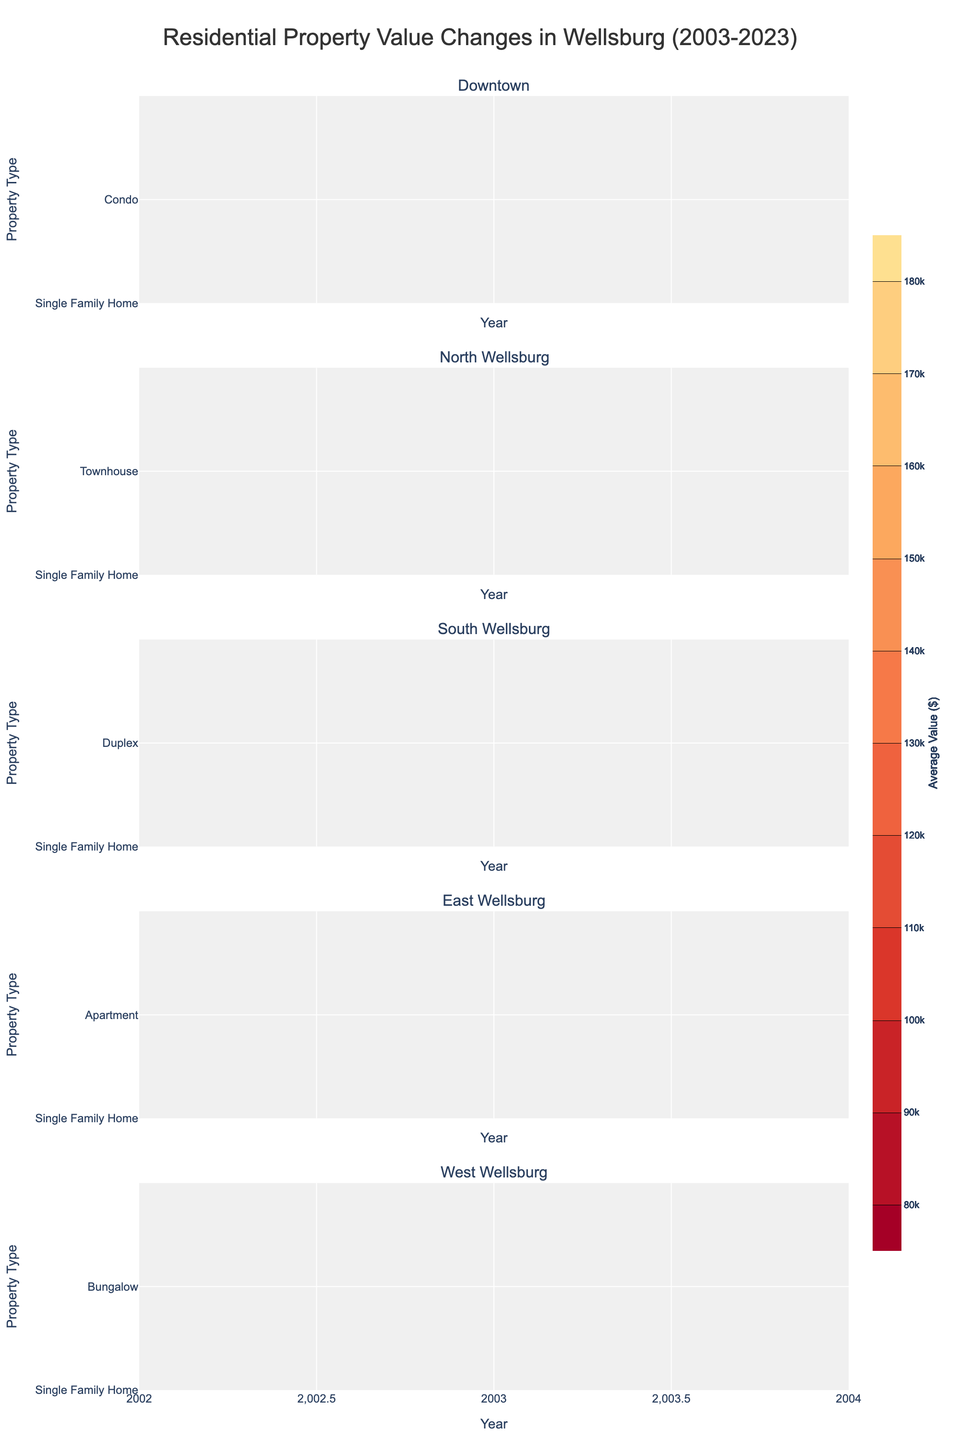What is the title of the figure? The title of the figure is displayed at the top of the plot. It provides an overview of what the entire figure represents.
Answer: Residential Property Value Changes in Wellsburg (2003-2023) Which neighborhood shows the highest increase in property value for Single Family Homes from 2003 to 2023? To find this, compare the contour lines for Single Family Homes across all neighborhoods from 2003 to 2023. Look for the largest increase in average value.
Answer: Downtown What is the average value of a Condo in Downtown Wellsburg in 2023? Look at the contour for Downtown and locate the values for Condos in 2023. The average value here can be read directly.
Answer: $150,000 How does the property value of Townhouses in North Wellsburg compare to Bungalows in West Wellsburg in 2023? Examine the contour lines for both property types in their respective neighborhoods for the year 2023. Compare the values directly.
Answer: Townhouses: $140,000, Bungalows: $130,000 Which neighborhood had the highest average property value for any property type in 2003? Check the contour plots for each neighborhood for the year 2003. Identify which property type in which neighborhood has the highest value.
Answer: Downtown (Single Family Home) What is the trend in property values for Single Family Homes in East Wellsburg over the 20 years? Look at the contour for Single Family Homes in East Wellsburg from 2003 to 2023. Determine if the values are increasing, decreasing, or stable.
Answer: Increasing Compare the property values of Duplexes in the South Wellsburg and Townhouses in North Wellsburg in 2013. Locate the values for Duplexes in South Wellsburg and Townhouses in North Wellsburg for the year 2013. Compare the two values directly.
Answer: Duplexes: $115,000, Townhouses: $110,000 How significant is the increase in property values for Apartments in East Wellsburg from 2008 to 2023? Find the property values for Apartments in East Wellsburg for the years 2008 and 2023 using the contour lines. Subtract the 2008 value from the 2023 value to find the increase.
Answer: Increase of $35,000 Which property type had the most consistent value increase across all neighborhoods? By comparing the contour plots for each property type in all neighborhoods, see which property type shows the most uniform trend of increasing values.
Answer: Single Family Home 